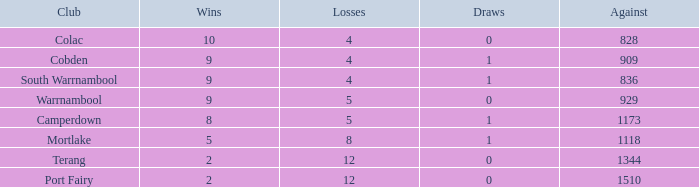What is the sum of losses for Against values over 1510? None. 